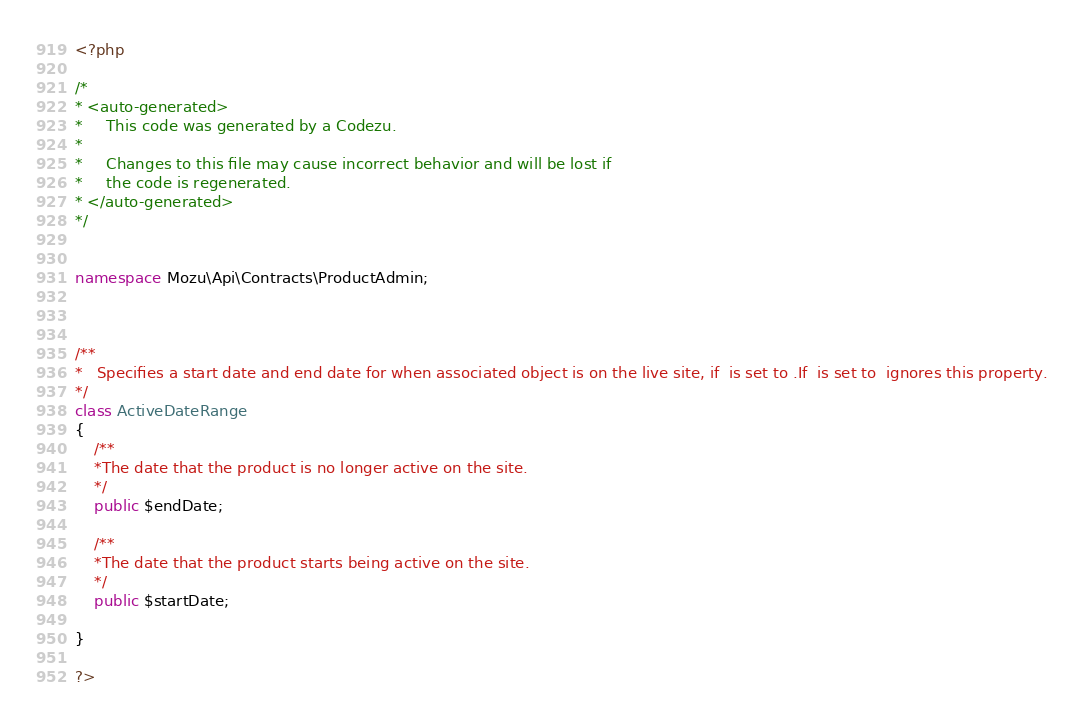Convert code to text. <code><loc_0><loc_0><loc_500><loc_500><_PHP_><?php

/*
* <auto-generated>
*     This code was generated by a Codezu.     
*
*     Changes to this file may cause incorrect behavior and will be lost if
*     the code is regenerated.
* </auto-generated>
*/


namespace Mozu\Api\Contracts\ProductAdmin;



/**
*	Specifies a start date and end date for when associated object is on the live site, if  is set to .If  is set to  ignores this property.
*/
class ActiveDateRange
{
	/**
	*The date that the product is no longer active on the site.
	*/
	public $endDate;

	/**
	*The date that the product starts being active on the site.
	*/
	public $startDate;

}

?>
</code> 